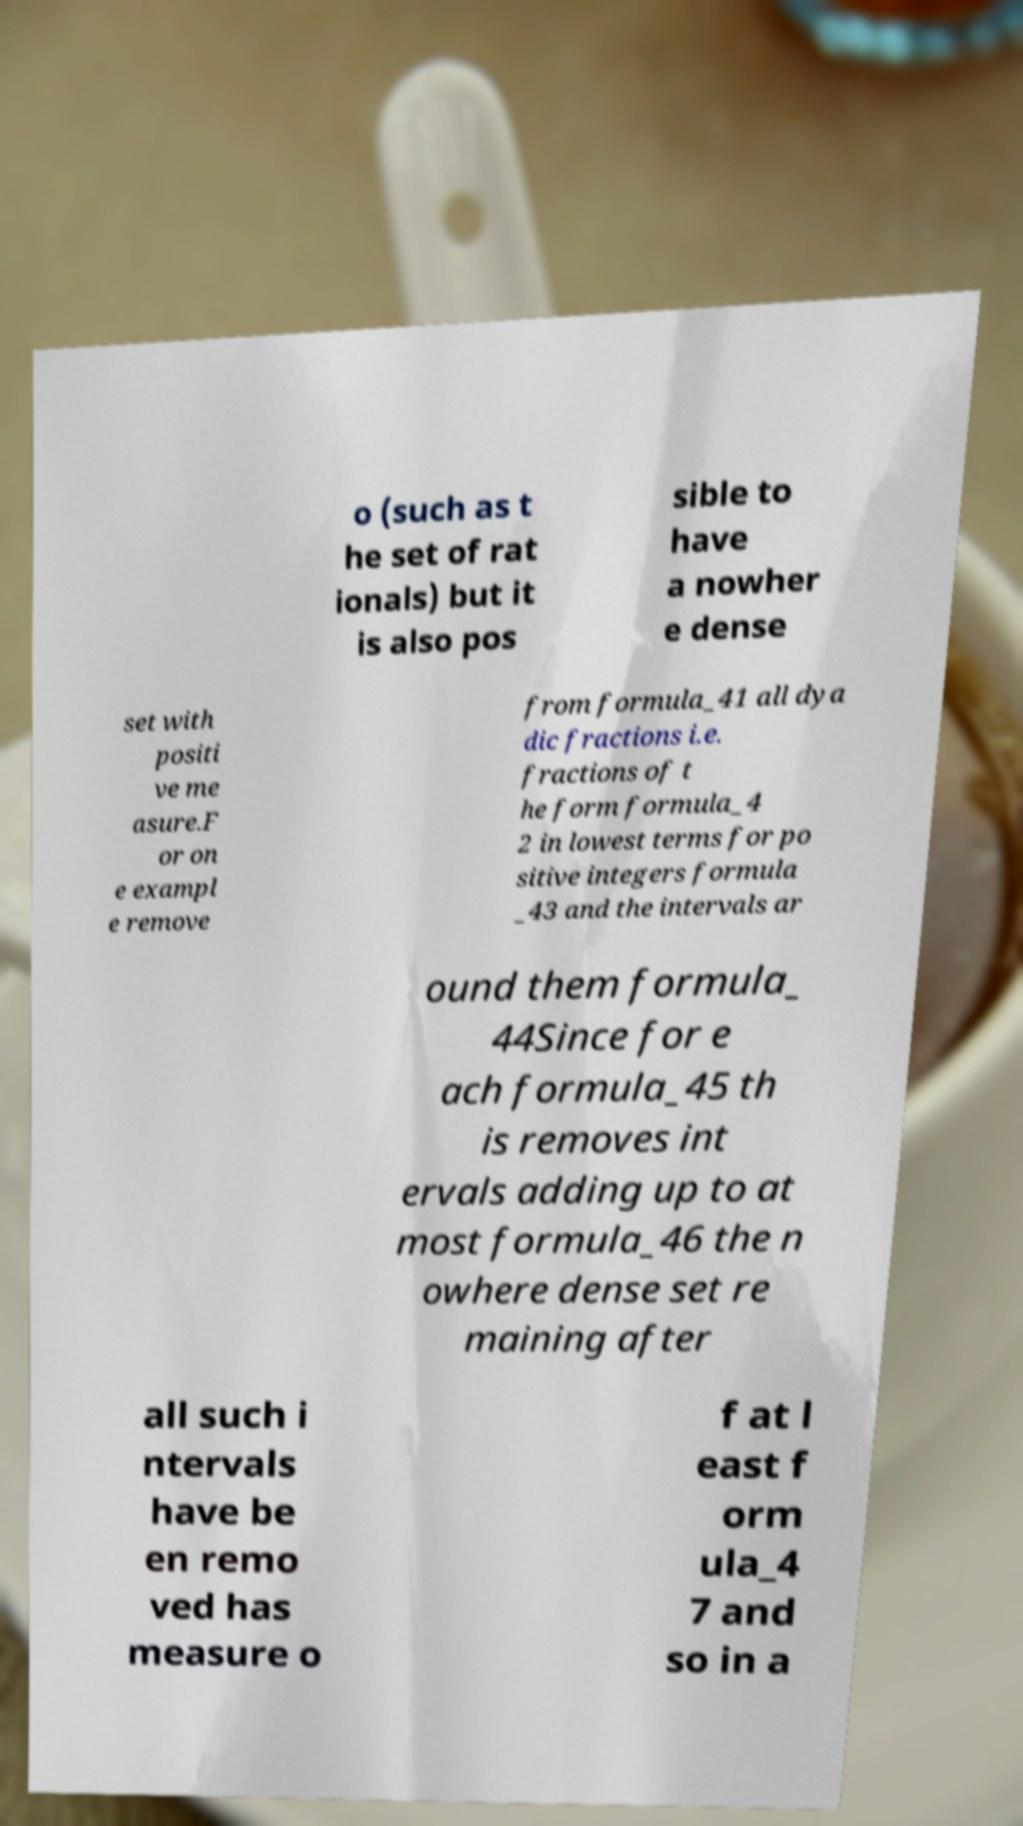What messages or text are displayed in this image? I need them in a readable, typed format. o (such as t he set of rat ionals) but it is also pos sible to have a nowher e dense set with positi ve me asure.F or on e exampl e remove from formula_41 all dya dic fractions i.e. fractions of t he form formula_4 2 in lowest terms for po sitive integers formula _43 and the intervals ar ound them formula_ 44Since for e ach formula_45 th is removes int ervals adding up to at most formula_46 the n owhere dense set re maining after all such i ntervals have be en remo ved has measure o f at l east f orm ula_4 7 and so in a 